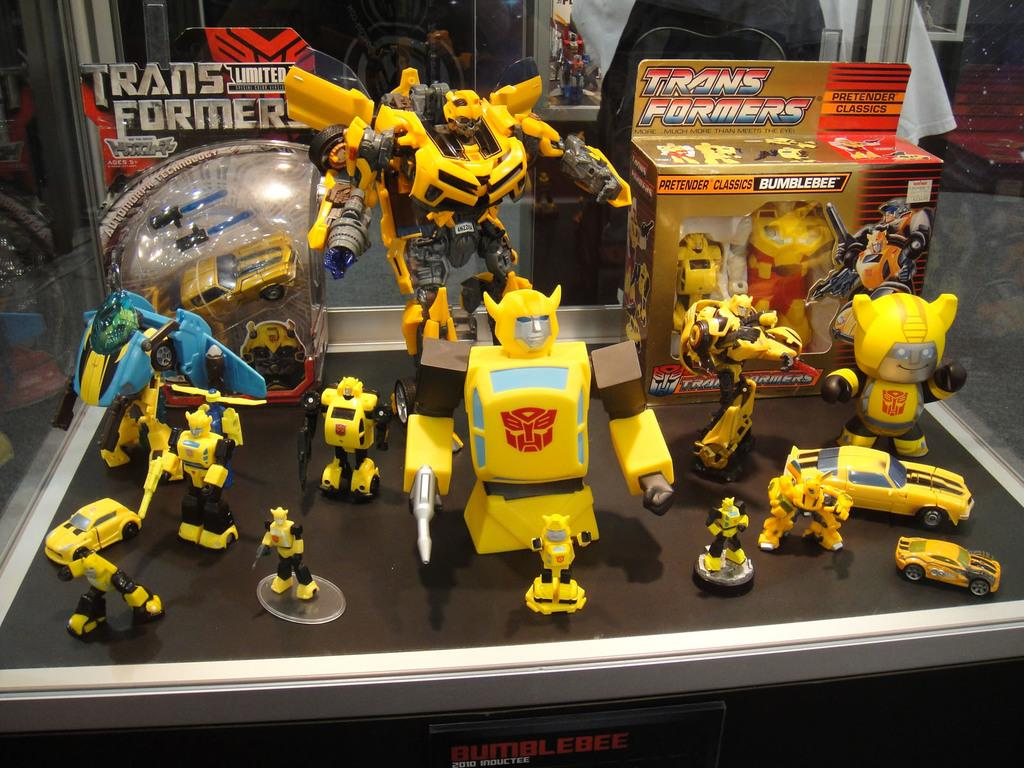What objects are on the table in the image? There are toys and a box on the table in the image. What can be seen in the background of the image? There is a cloth and a bench in the background of the image. What type of celery can be seen growing on the bench in the image? There is no celery present in the image; the bench is empty in the background. 